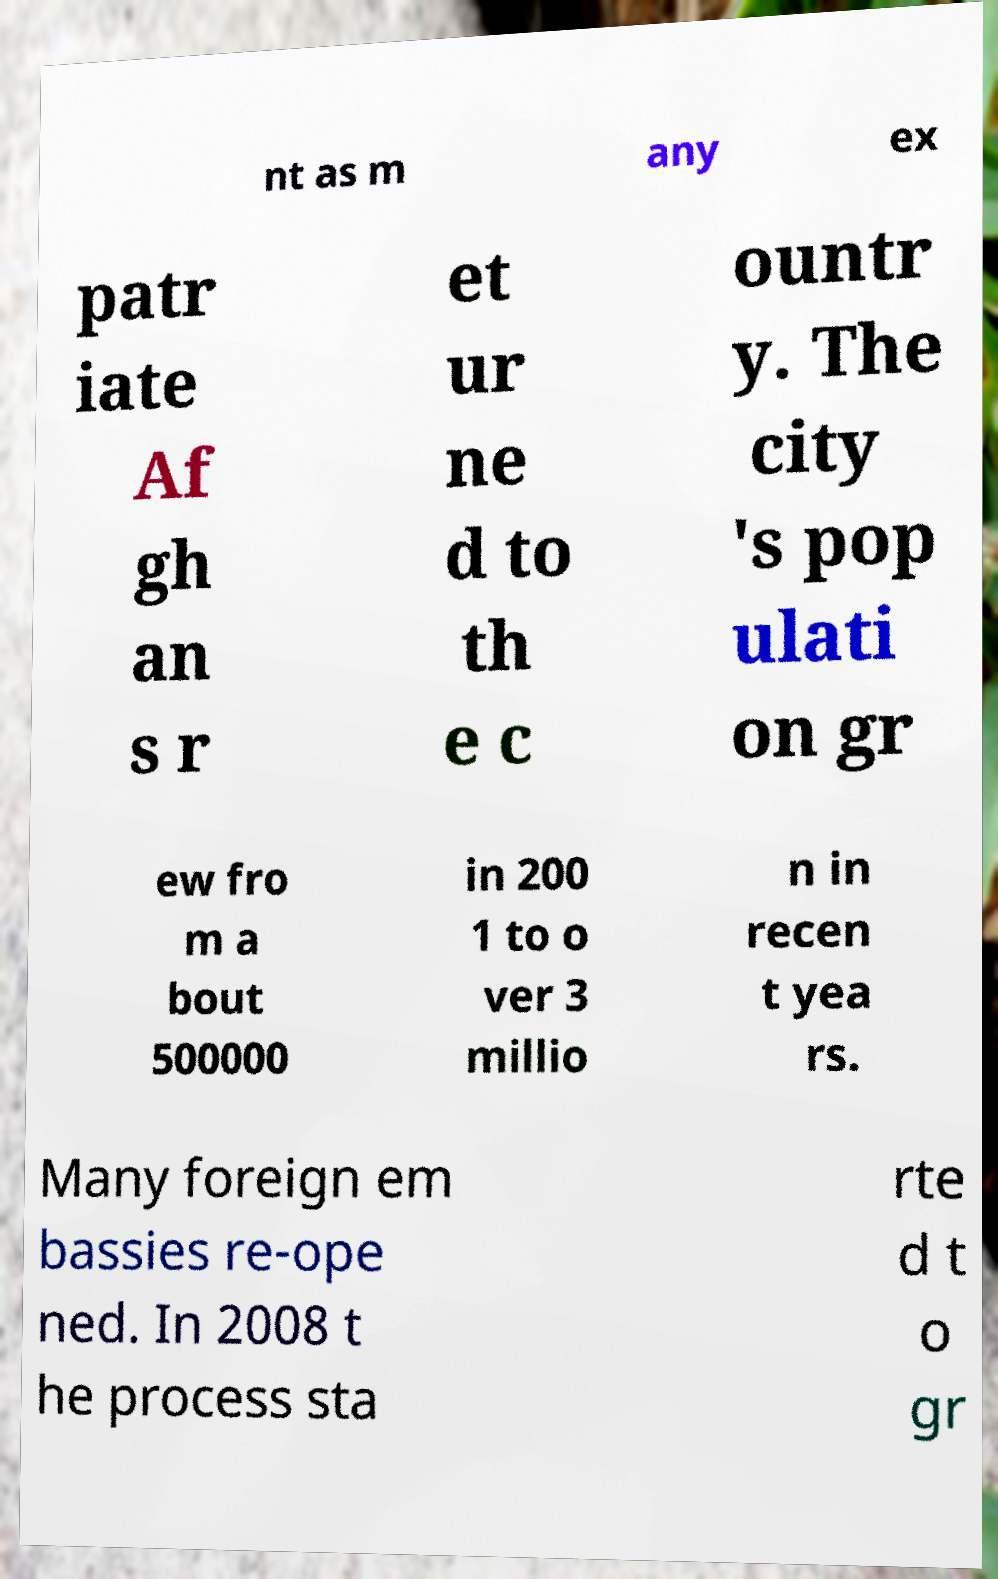Please identify and transcribe the text found in this image. nt as m any ex patr iate Af gh an s r et ur ne d to th e c ountr y. The city 's pop ulati on gr ew fro m a bout 500000 in 200 1 to o ver 3 millio n in recen t yea rs. Many foreign em bassies re-ope ned. In 2008 t he process sta rte d t o gr 